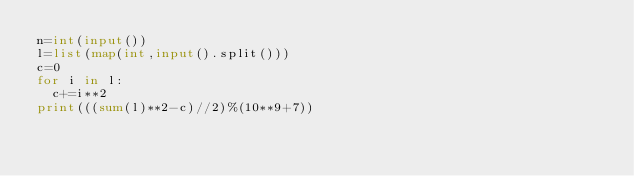Convert code to text. <code><loc_0><loc_0><loc_500><loc_500><_Python_>n=int(input())
l=list(map(int,input().split()))
c=0
for i in l:
	c+=i**2
print(((sum(l)**2-c)//2)%(10**9+7))</code> 